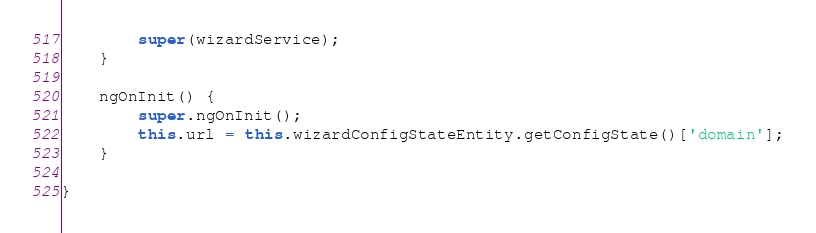<code> <loc_0><loc_0><loc_500><loc_500><_TypeScript_>        super(wizardService);
    }

    ngOnInit() {
        super.ngOnInit();
        this.url = this.wizardConfigStateEntity.getConfigState()['domain'];
    }

}
</code> 